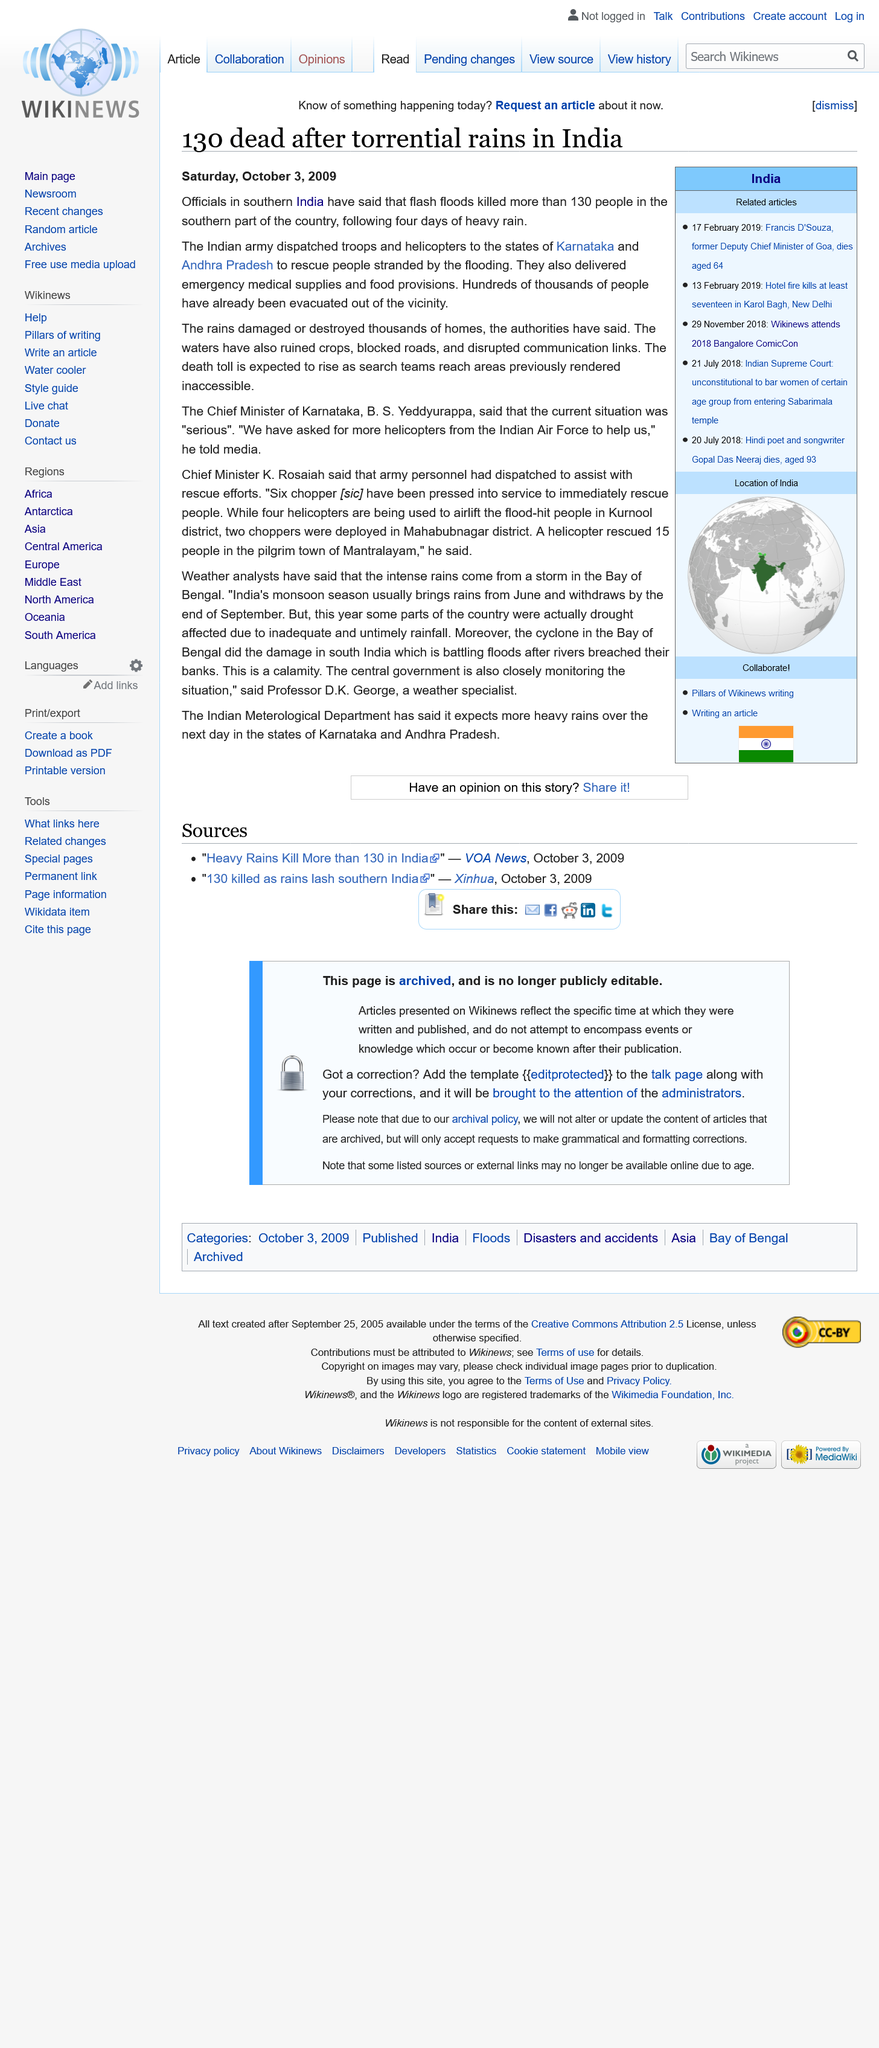Specify some key components in this picture. Mr B. S. Yeddyurappa is the Chief Minister of Karnataka. It is estimated that 130 people were killed by the flash flood. The articles were published on Saturday, October 3, 2009. 